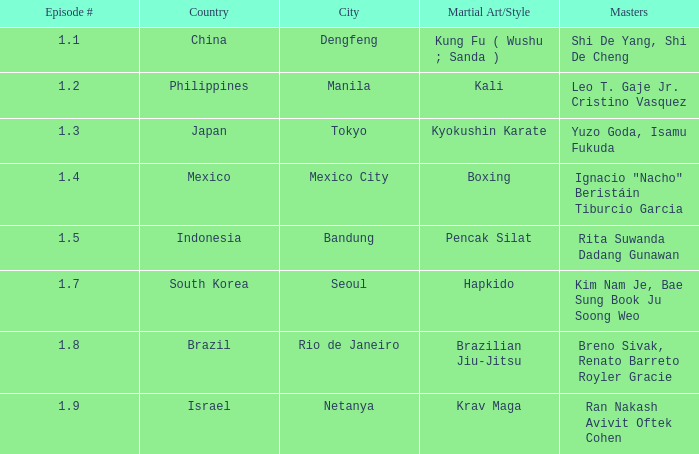How many times did episode 1.8 air? 1.0. 